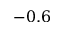Convert formula to latex. <formula><loc_0><loc_0><loc_500><loc_500>- 0 . 6</formula> 